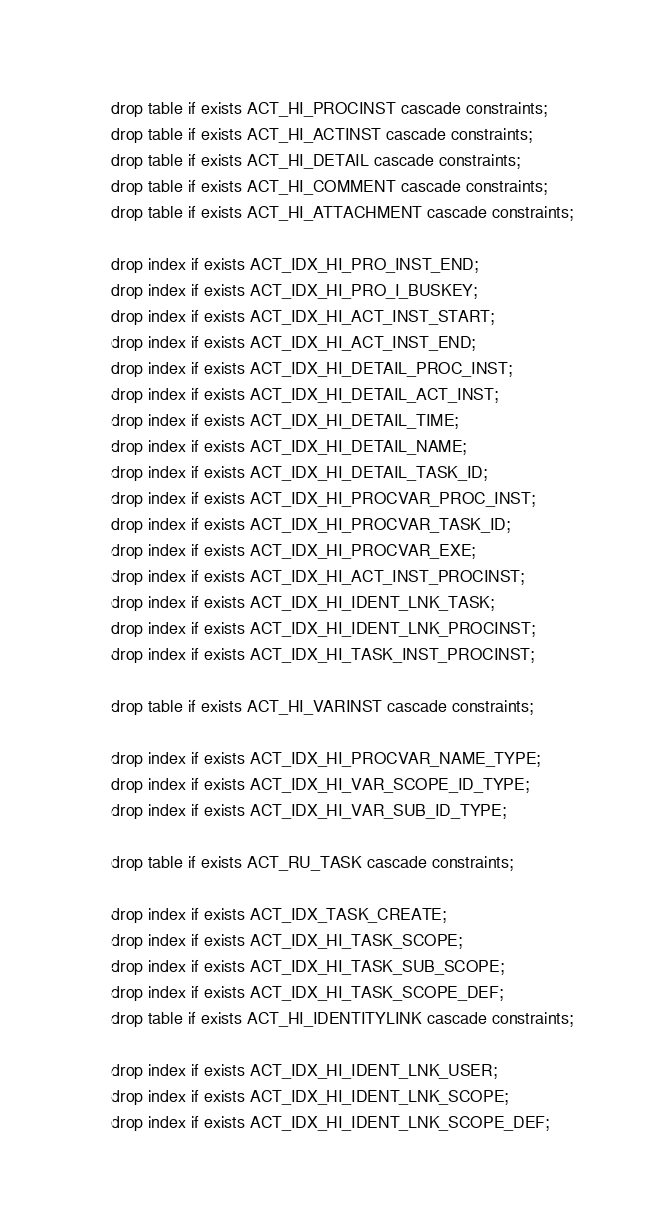<code> <loc_0><loc_0><loc_500><loc_500><_SQL_>drop table if exists ACT_HI_PROCINST cascade constraints;
drop table if exists ACT_HI_ACTINST cascade constraints;
drop table if exists ACT_HI_DETAIL cascade constraints;
drop table if exists ACT_HI_COMMENT cascade constraints;
drop table if exists ACT_HI_ATTACHMENT cascade constraints;

drop index if exists ACT_IDX_HI_PRO_INST_END;
drop index if exists ACT_IDX_HI_PRO_I_BUSKEY;
drop index if exists ACT_IDX_HI_ACT_INST_START;
drop index if exists ACT_IDX_HI_ACT_INST_END;
drop index if exists ACT_IDX_HI_DETAIL_PROC_INST;
drop index if exists ACT_IDX_HI_DETAIL_ACT_INST;
drop index if exists ACT_IDX_HI_DETAIL_TIME;
drop index if exists ACT_IDX_HI_DETAIL_NAME;
drop index if exists ACT_IDX_HI_DETAIL_TASK_ID;
drop index if exists ACT_IDX_HI_PROCVAR_PROC_INST;
drop index if exists ACT_IDX_HI_PROCVAR_TASK_ID;
drop index if exists ACT_IDX_HI_PROCVAR_EXE;
drop index if exists ACT_IDX_HI_ACT_INST_PROCINST;
drop index if exists ACT_IDX_HI_IDENT_LNK_TASK;
drop index if exists ACT_IDX_HI_IDENT_LNK_PROCINST;
drop index if exists ACT_IDX_HI_TASK_INST_PROCINST;

drop table if exists ACT_HI_VARINST cascade constraints;

drop index if exists ACT_IDX_HI_PROCVAR_NAME_TYPE;
drop index if exists ACT_IDX_HI_VAR_SCOPE_ID_TYPE;
drop index if exists ACT_IDX_HI_VAR_SUB_ID_TYPE;

drop table if exists ACT_RU_TASK cascade constraints;

drop index if exists ACT_IDX_TASK_CREATE;
drop index if exists ACT_IDX_HI_TASK_SCOPE;
drop index if exists ACT_IDX_HI_TASK_SUB_SCOPE;
drop index if exists ACT_IDX_HI_TASK_SCOPE_DEF;
drop table if exists ACT_HI_IDENTITYLINK cascade constraints;

drop index if exists ACT_IDX_HI_IDENT_LNK_USER;
drop index if exists ACT_IDX_HI_IDENT_LNK_SCOPE;
drop index if exists ACT_IDX_HI_IDENT_LNK_SCOPE_DEF;
</code> 